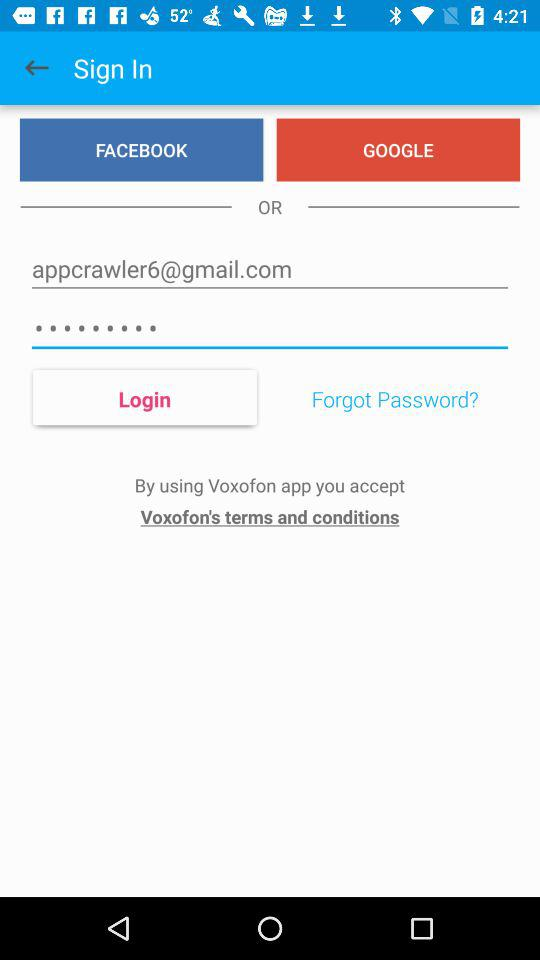How many characters are required to create a password?
When the provided information is insufficient, respond with <no answer>. <no answer> 